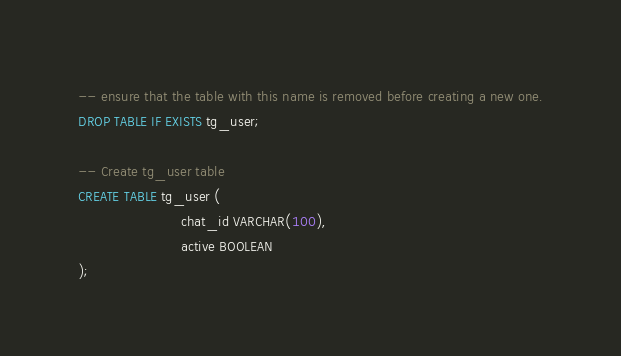<code> <loc_0><loc_0><loc_500><loc_500><_SQL_>-- ensure that the table with this name is removed before creating a new one.
DROP TABLE IF EXISTS tg_user;

-- Create tg_user table
CREATE TABLE tg_user (
                         chat_id VARCHAR(100),
                         active BOOLEAN
);
</code> 